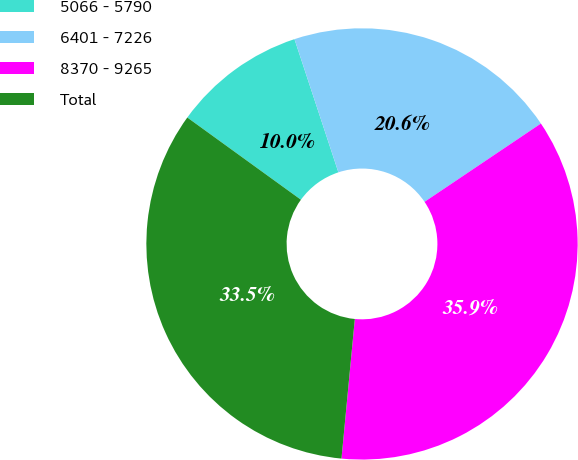Convert chart. <chart><loc_0><loc_0><loc_500><loc_500><pie_chart><fcel>5066 - 5790<fcel>6401 - 7226<fcel>8370 - 9265<fcel>Total<nl><fcel>9.96%<fcel>20.64%<fcel>35.94%<fcel>33.45%<nl></chart> 